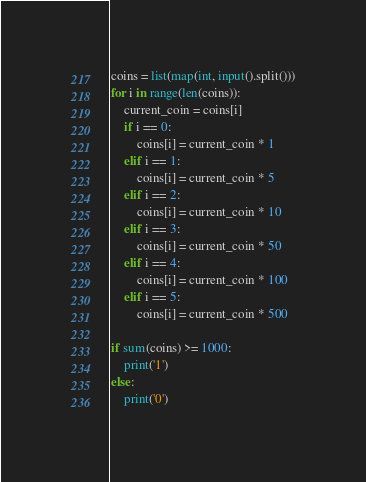<code> <loc_0><loc_0><loc_500><loc_500><_Python_>coins = list(map(int, input().split()))
for i in range(len(coins)):
    current_coin = coins[i]
    if i == 0:
        coins[i] = current_coin * 1
    elif i == 1:
        coins[i] = current_coin * 5
    elif i == 2:
        coins[i] = current_coin * 10
    elif i == 3:
        coins[i] = current_coin * 50
    elif i == 4:
        coins[i] = current_coin * 100
    elif i == 5:
        coins[i] = current_coin * 500
 
if sum(coins) >= 1000:
    print('1')
else:
    print('0')
</code> 